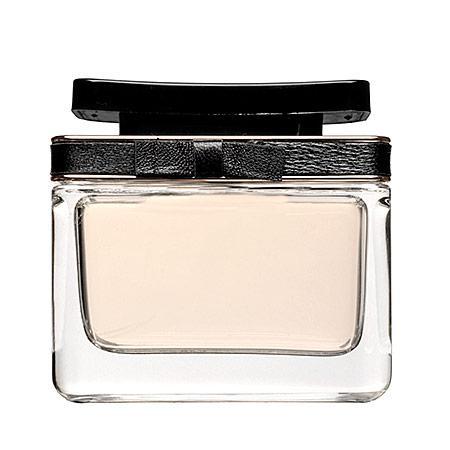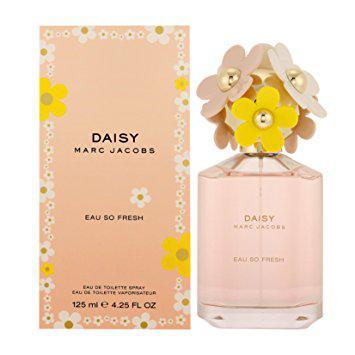The first image is the image on the left, the second image is the image on the right. Assess this claim about the two images: "A perfume bottle in one image is topped with a decorative cap that is covered with plastic daisies.". Correct or not? Answer yes or no. Yes. 